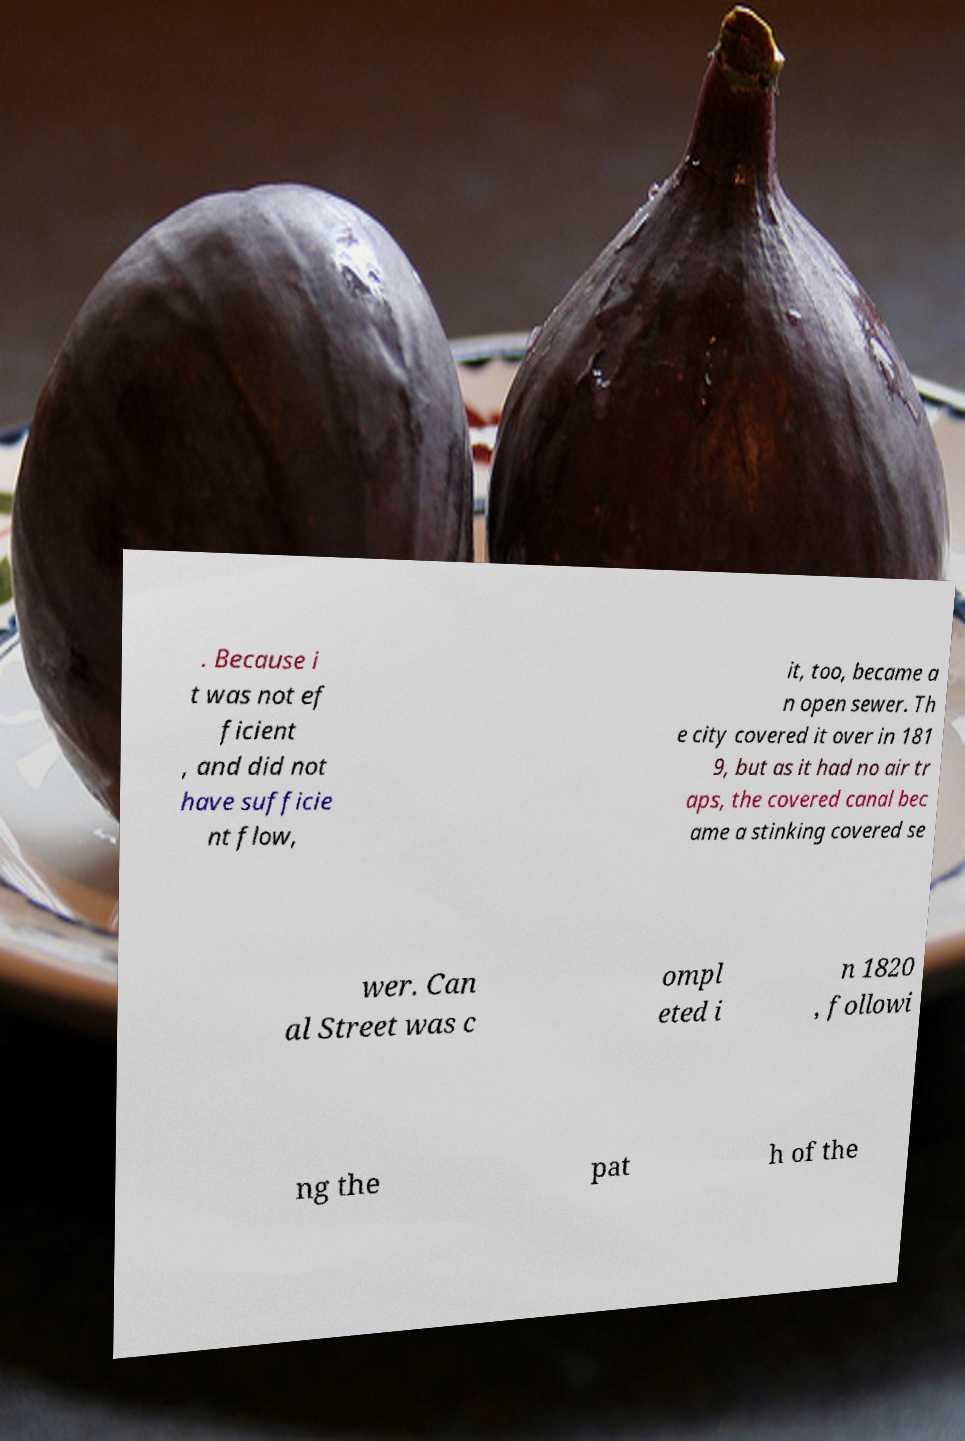What messages or text are displayed in this image? I need them in a readable, typed format. . Because i t was not ef ficient , and did not have sufficie nt flow, it, too, became a n open sewer. Th e city covered it over in 181 9, but as it had no air tr aps, the covered canal bec ame a stinking covered se wer. Can al Street was c ompl eted i n 1820 , followi ng the pat h of the 